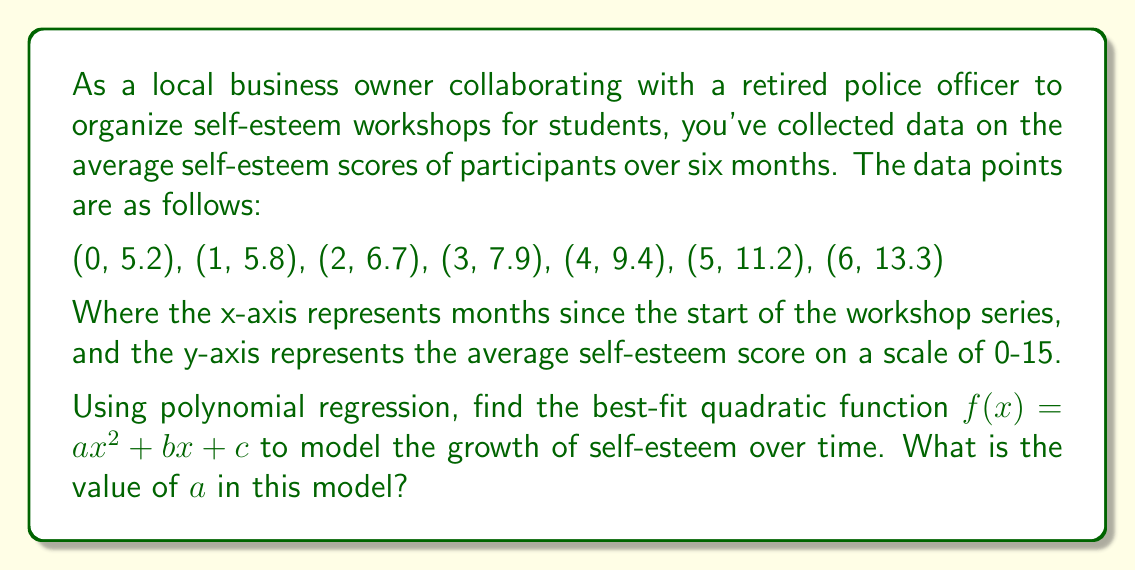Can you solve this math problem? To find the best-fit quadratic function using polynomial regression, we'll use the least squares method. We need to solve a system of equations to find $a$, $b$, and $c$.

Step 1: Set up the system of equations:
$$\begin{cases}
\sum y = an\sum x^2 + b\sum x + cn \\
\sum xy = a\sum x^3 + b\sum x^2 + c\sum x \\
\sum x^2y = a\sum x^4 + b\sum x^3 + c\sum x^2
\end{cases}$$

Step 2: Calculate the required sums:
$n = 7$
$\sum x = 0 + 1 + 2 + 3 + 4 + 5 + 6 = 21$
$\sum x^2 = 0 + 1 + 4 + 9 + 16 + 25 + 36 = 91$
$\sum x^3 = 0 + 1 + 8 + 27 + 64 + 125 + 216 = 441$
$\sum x^4 = 0 + 1 + 16 + 81 + 256 + 625 + 1296 = 2275$
$\sum y = 5.2 + 5.8 + 6.7 + 7.9 + 9.4 + 11.2 + 13.3 = 59.5$
$\sum xy = 0 + 5.8 + 13.4 + 23.7 + 37.6 + 56 + 79.8 = 216.3$
$\sum x^2y = 0 + 5.8 + 26.8 + 71.1 + 150.4 + 280 + 478.8 = 1012.9$

Step 3: Substitute the values into the system of equations:
$$\begin{cases}
59.5 = 91a + 21b + 7c \\
216.3 = 441a + 91b + 21c \\
1012.9 = 2275a + 441b + 91c
\end{cases}$$

Step 4: Solve the system of equations using elimination or matrix methods. After solving, we get:

$a \approx 0.1429$
$b \approx 0.6071$
$c \approx 5.2000$

Therefore, the best-fit quadratic function is:
$f(x) \approx 0.1429x^2 + 0.6071x + 5.2000$

The question asks for the value of $a$, which is approximately 0.1429.
Answer: $a \approx 0.1429$ 